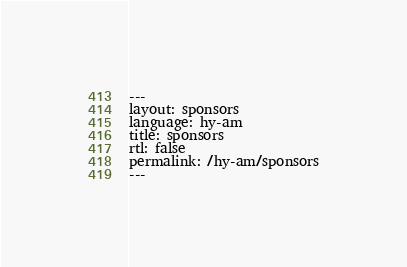<code> <loc_0><loc_0><loc_500><loc_500><_HTML_>---
layout: sponsors
language: hy-am
title: sponsors
rtl: false
permalink: /hy-am/sponsors
---
</code> 